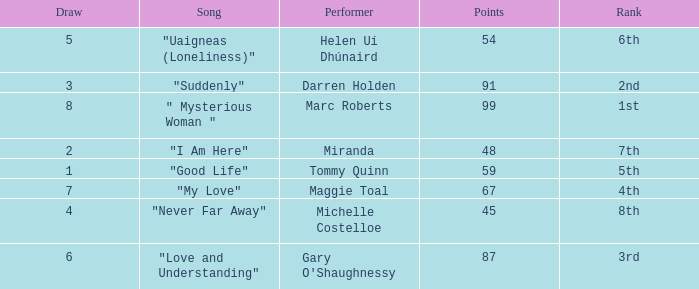What is the average number of points for a song ranked 2nd with a draw greater than 3? None. 